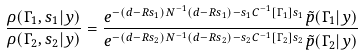Convert formula to latex. <formula><loc_0><loc_0><loc_500><loc_500>\frac { \rho ( \Gamma _ { 1 } , s _ { 1 } | y ) } { \rho ( \Gamma _ { 2 } , s _ { 2 } | y ) } = \frac { e ^ { - ( d - R s _ { 1 } ) N ^ { - 1 } ( d - R s _ { 1 } ) - s _ { 1 } C ^ { - 1 } [ \Gamma _ { 1 } ] s _ { 1 } } { \tilde { p } } ( \Gamma _ { 1 } | y ) } { e ^ { - ( d - R s _ { 2 } ) N ^ { - 1 } ( d - R s _ { 2 } ) - s _ { 2 } C ^ { - 1 } [ \Gamma _ { 2 } ] s _ { 2 } } { \tilde { p } } ( \Gamma _ { 2 } | y ) }</formula> 